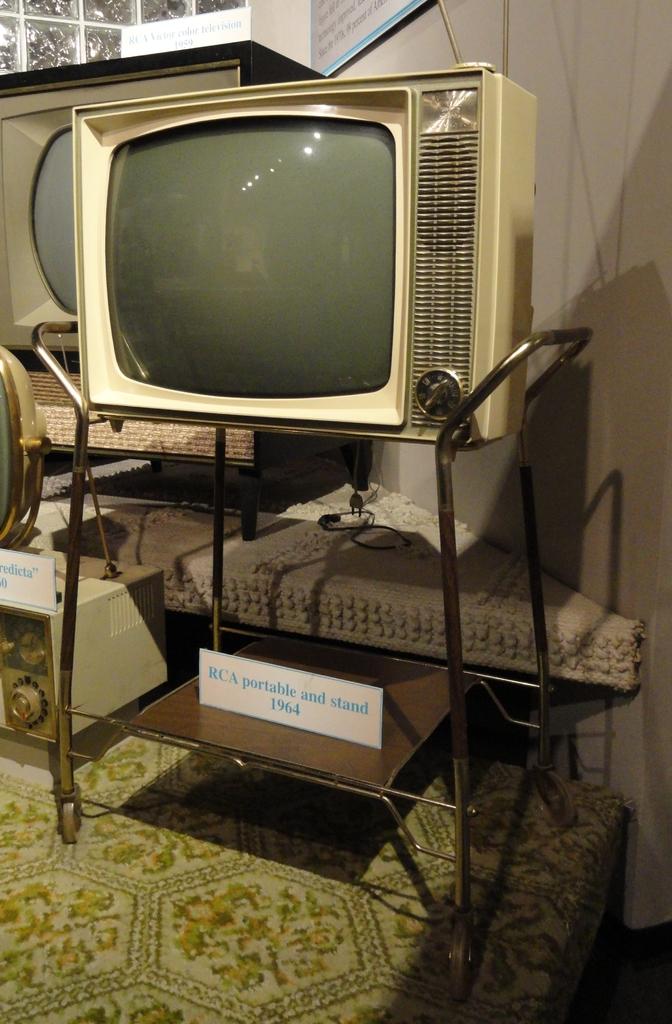What is the year on the tag under the tv?
Your response must be concise. 1964. 